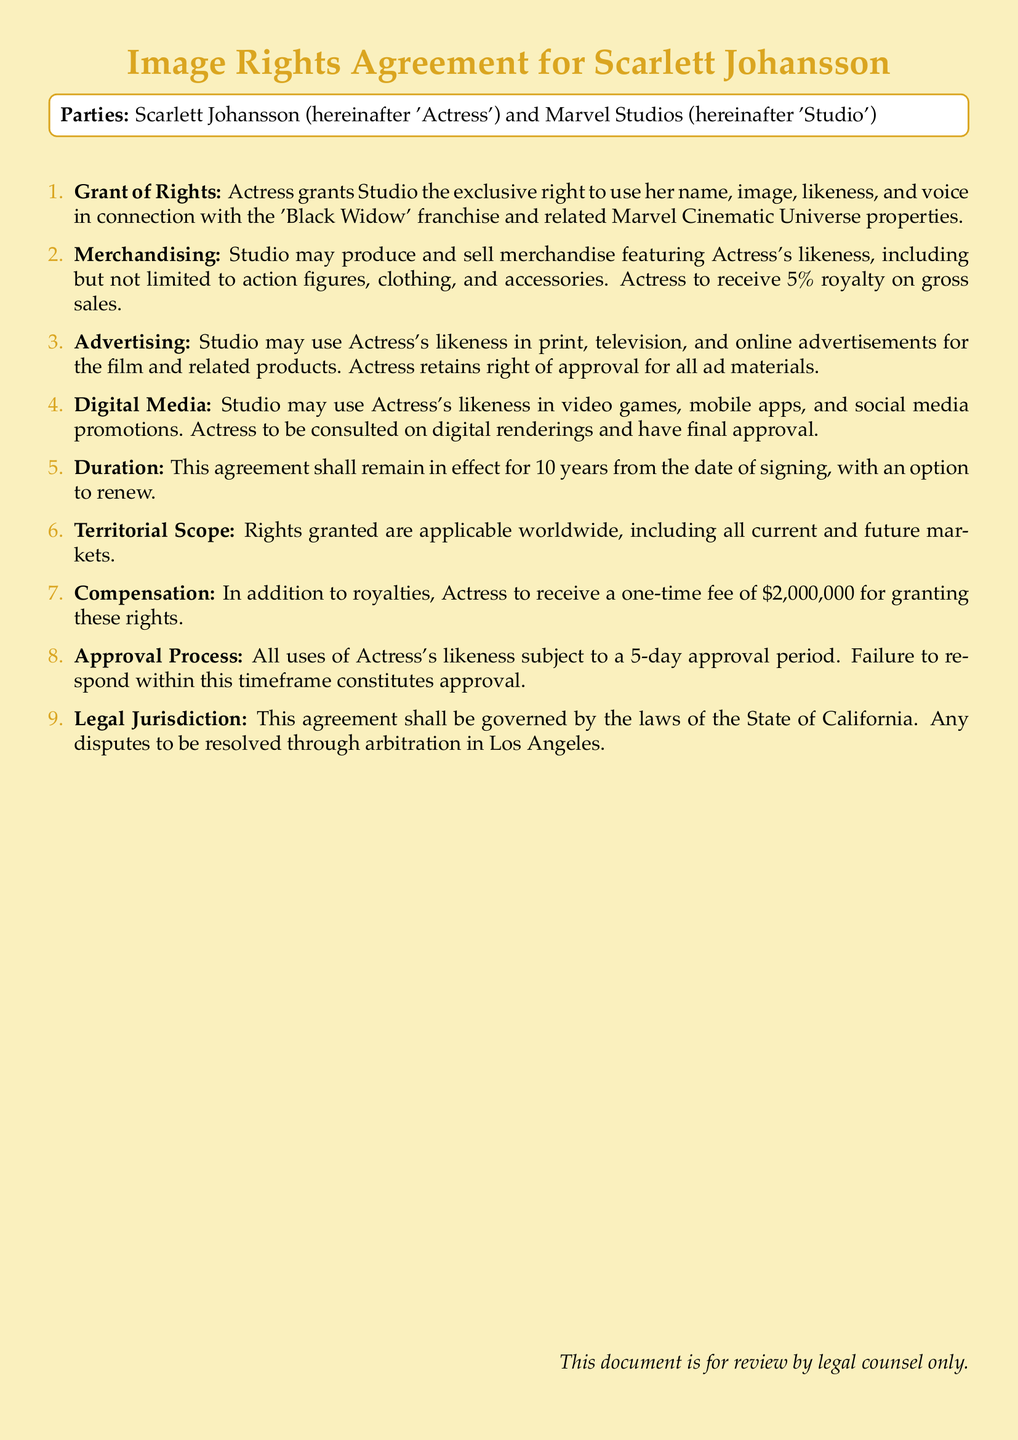What is the name of the actress in the agreement? The actress involved in the agreement is specified at the beginning of the document as 'Scarlett Johansson'.
Answer: Scarlett Johansson Who is the studio involved in this agreement? The studio that is part of this agreement is listed in the document as 'Marvel Studios'.
Answer: Marvel Studios What percentage royalty does the actress receive from merchandise sales? The document specifies that the actress will receive a 5% royalty on gross merchandise sales.
Answer: 5% How long is the duration of this agreement? The duration specified in the document states that it shall remain in effect for 10 years from the date of signing.
Answer: 10 years What is the one-time fee the actress will receive? The document states that the actress will receive a one-time fee of $2,000,000 for granting these rights.
Answer: $2,000,000 What type of advertising can the studio use the actress's likeness in? The document mentions that the studio may use the actress's likeness in print, television, and online advertisements.
Answer: print, television, and online What is required for the actress regarding ad materials? According to the document, the actress retains the right of approval for all ad materials.
Answer: right of approval Where will disputes be resolved according to the agreement? The document states that any disputes should be resolved through arbitration in Los Angeles.
Answer: Los Angeles What does the approval process entail for uses of the actress's likeness? The document specifies that there is a 5-day approval period for all uses of the actress's likeness.
Answer: 5-day approval period 